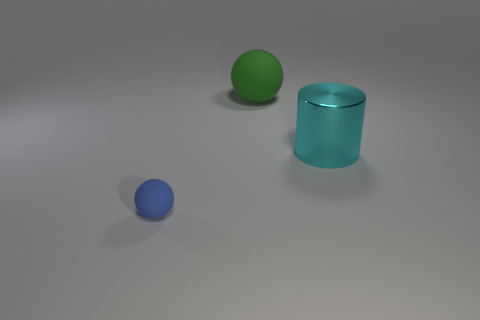Add 3 small blue cubes. How many objects exist? 6 Subtract all cylinders. How many objects are left? 2 Subtract 1 blue balls. How many objects are left? 2 Subtract all small matte objects. Subtract all yellow matte balls. How many objects are left? 2 Add 2 green spheres. How many green spheres are left? 3 Add 2 large cyan metallic cylinders. How many large cyan metallic cylinders exist? 3 